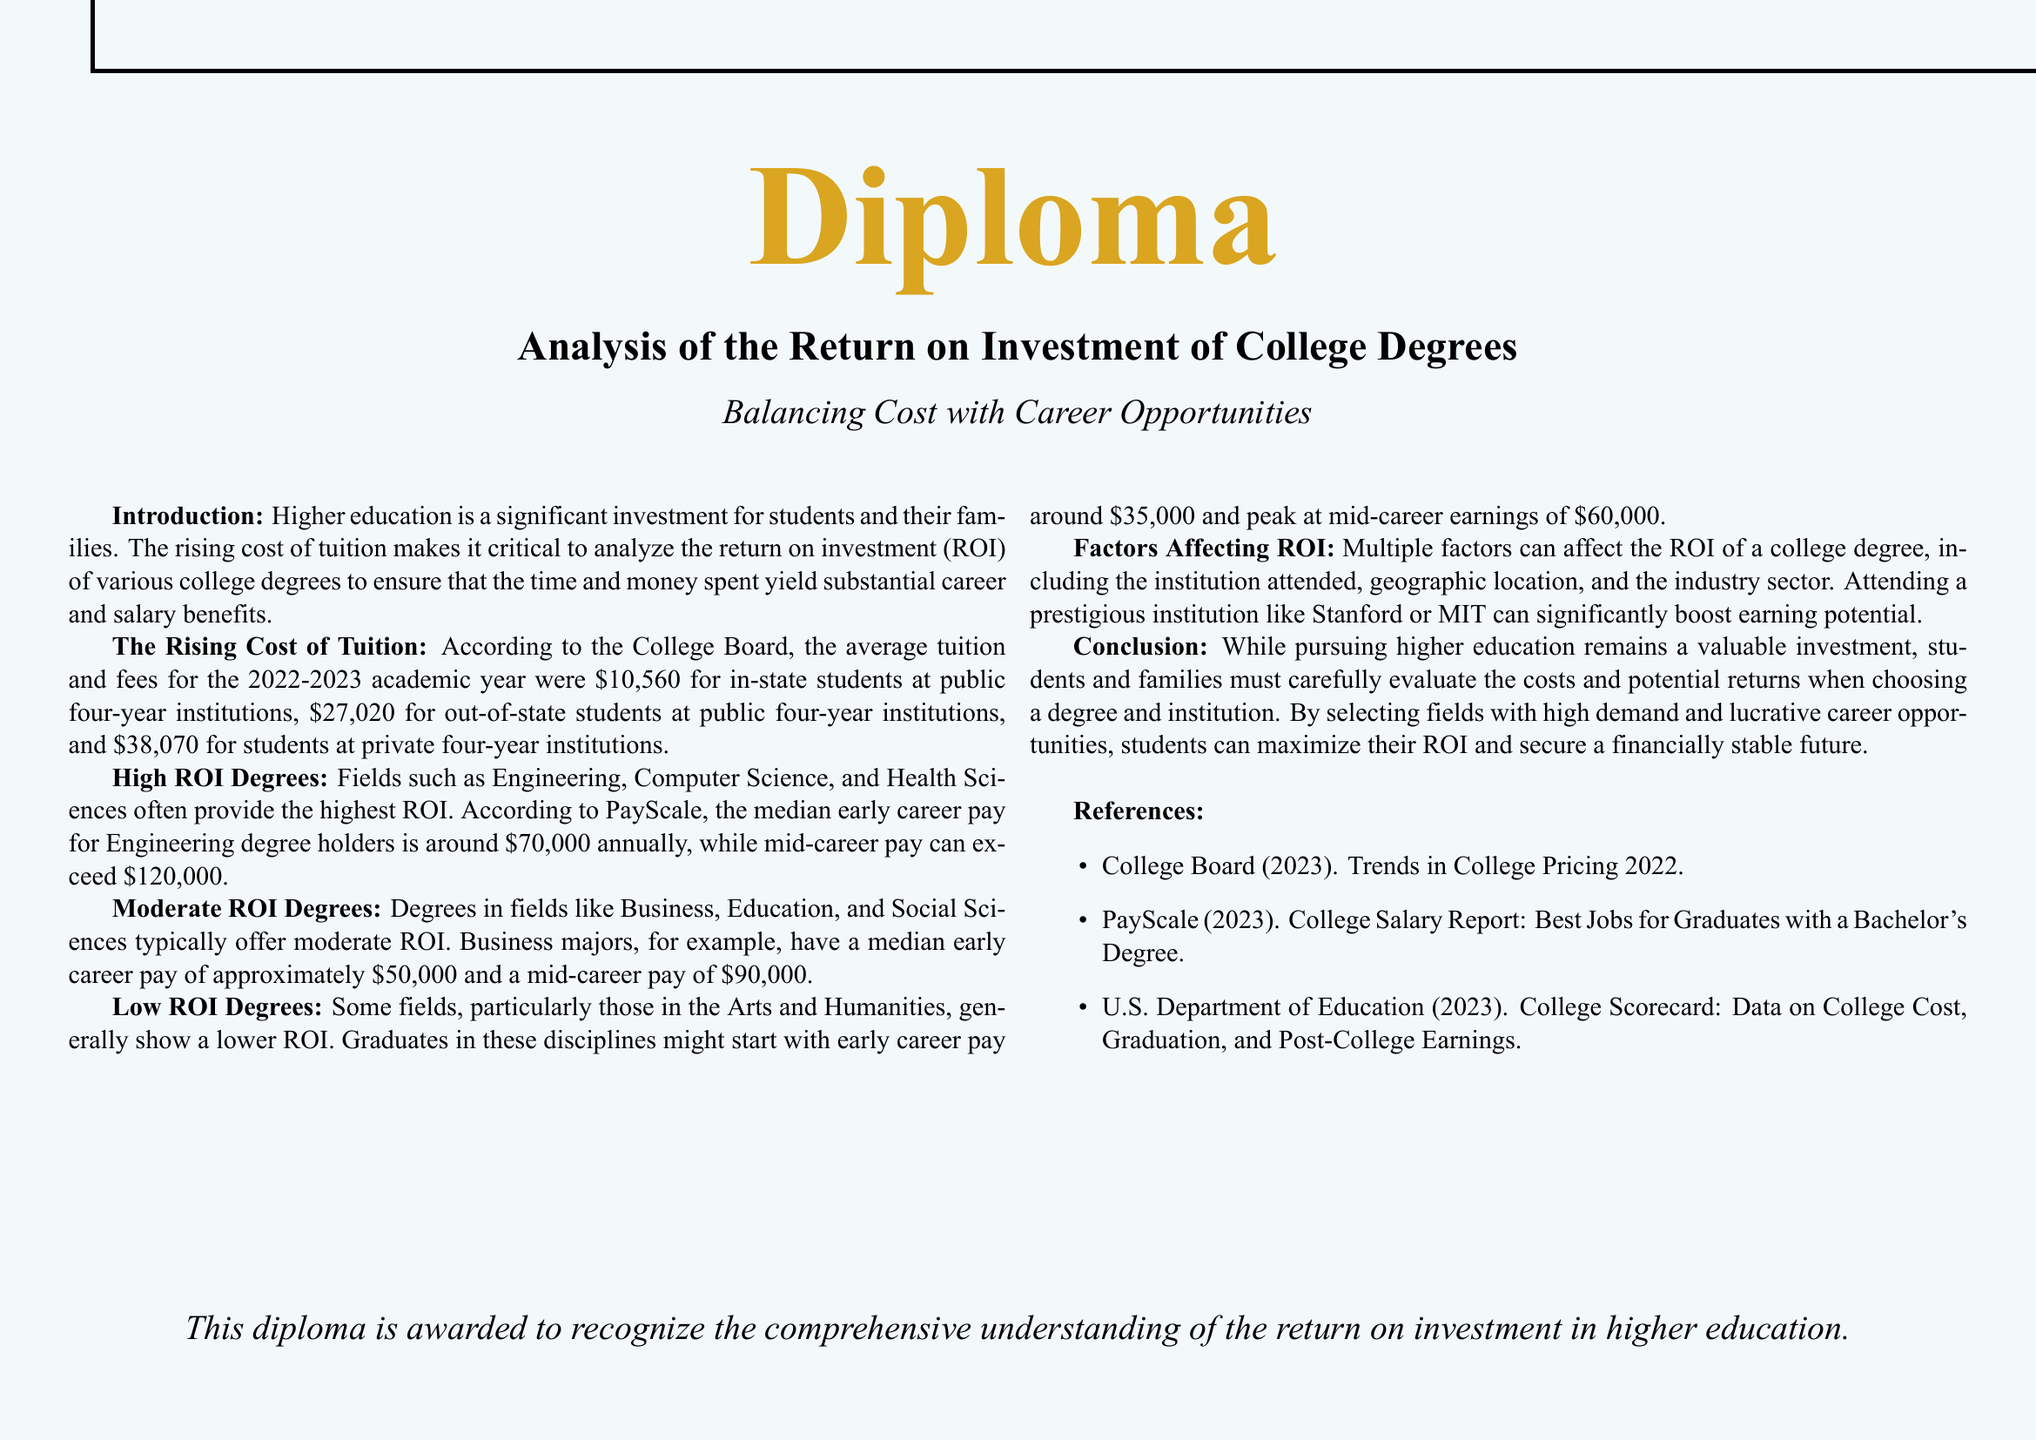What is the average tuition for in-state students? The average tuition and fees for in-state students at public four-year institutions for the 2022-2023 academic year is mentioned to be $10,560.
Answer: $10,560 What field has the highest median early career pay? The document states that Engineering provides the highest median early career pay amongst fields.
Answer: Engineering What is the mid-career pay for Business majors? According to the document, the mid-career pay for Business majors is approximately $90,000.
Answer: $90,000 Which factor can significantly boost earning potential? The document highlights attending a prestigious institution as a factor that can significantly boost earning potential.
Answer: Prestigious institution What is the lowest mid-career earnings mentioned in the document? The document indicates that graduates in the Arts and Humanities might peak at mid-career earnings around $60,000.
Answer: $60,000 What is the purpose of this diploma? The document states that this diploma is awarded to recognize the comprehensive understanding of the return on investment in higher education.
Answer: Recognize understanding What is the median early career pay for Engineering degree holders? The document specifies that the median early career pay for Engineering degree holders is around $70,000 annually.
Answer: $70,000 What is one of the references used in the document? The document references the College Board's Trends in College Pricing 2022 as one of the sources.
Answer: College Board Which degrees are categorized as low ROI? The document mentions degrees in Arts and Humanities as generally showing a lower ROI.
Answer: Arts and Humanities 